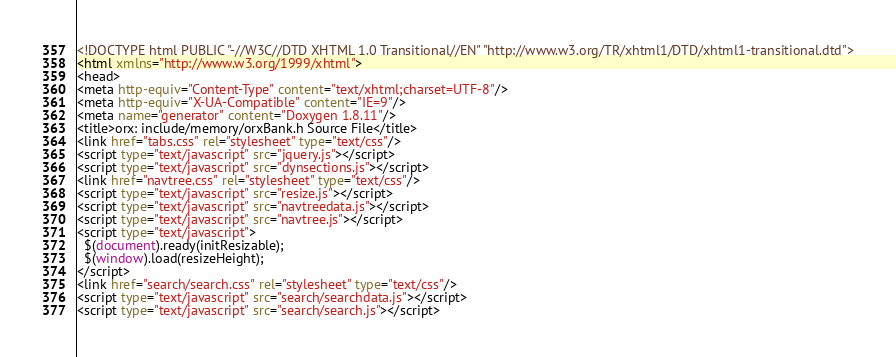Convert code to text. <code><loc_0><loc_0><loc_500><loc_500><_HTML_><!DOCTYPE html PUBLIC "-//W3C//DTD XHTML 1.0 Transitional//EN" "http://www.w3.org/TR/xhtml1/DTD/xhtml1-transitional.dtd">
<html xmlns="http://www.w3.org/1999/xhtml">
<head>
<meta http-equiv="Content-Type" content="text/xhtml;charset=UTF-8"/>
<meta http-equiv="X-UA-Compatible" content="IE=9"/>
<meta name="generator" content="Doxygen 1.8.11"/>
<title>orx: include/memory/orxBank.h Source File</title>
<link href="tabs.css" rel="stylesheet" type="text/css"/>
<script type="text/javascript" src="jquery.js"></script>
<script type="text/javascript" src="dynsections.js"></script>
<link href="navtree.css" rel="stylesheet" type="text/css"/>
<script type="text/javascript" src="resize.js"></script>
<script type="text/javascript" src="navtreedata.js"></script>
<script type="text/javascript" src="navtree.js"></script>
<script type="text/javascript">
  $(document).ready(initResizable);
  $(window).load(resizeHeight);
</script>
<link href="search/search.css" rel="stylesheet" type="text/css"/>
<script type="text/javascript" src="search/searchdata.js"></script>
<script type="text/javascript" src="search/search.js"></script></code> 